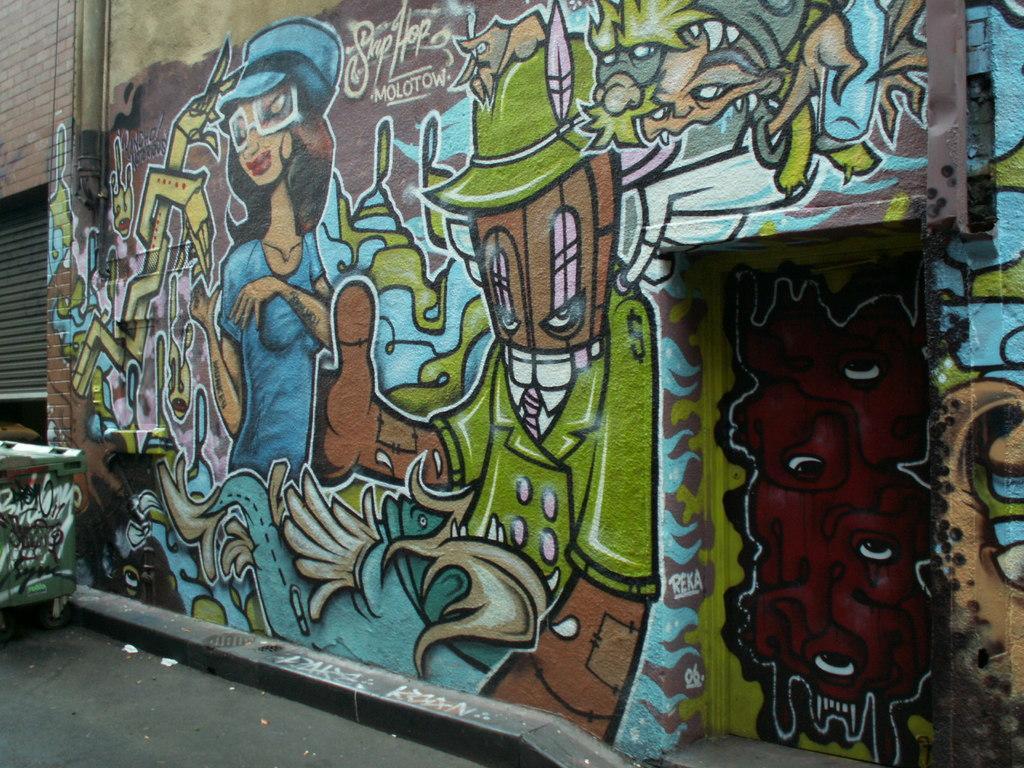In one or two sentences, can you explain what this image depicts? This image consists of a wall on which we can see the graffiti. On the left, there is a box. It looks like a dustbin. At the bottom, there is a road. 